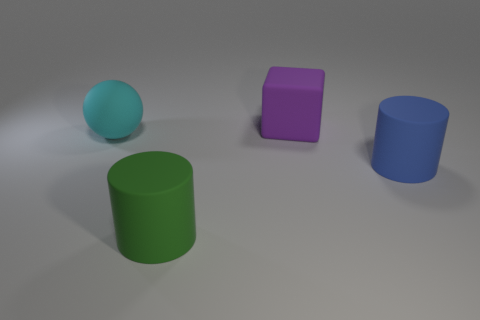There is a thing to the right of the cube; is it the same shape as the object that is in front of the large blue thing?
Your answer should be very brief. Yes. How many cubes are either gray things or large purple rubber things?
Offer a terse response. 1. Is the number of blue things that are on the left side of the matte cube less than the number of green matte objects?
Keep it short and to the point. Yes. How many other things are there of the same material as the cyan ball?
Your answer should be very brief. 3. What number of things are things behind the cyan matte ball or large rubber blocks?
Provide a short and direct response. 1. Is there a blue matte object of the same shape as the green object?
Your response must be concise. Yes. There is a cyan matte object; is its size the same as the matte cylinder that is to the left of the large blue thing?
Offer a very short reply. Yes. What number of things are either objects that are in front of the blue cylinder or rubber objects that are in front of the blue object?
Offer a very short reply. 1. Are there more large blue objects that are behind the large cyan rubber ball than things?
Keep it short and to the point. No. What number of rubber blocks have the same size as the cyan matte object?
Your answer should be compact. 1. 